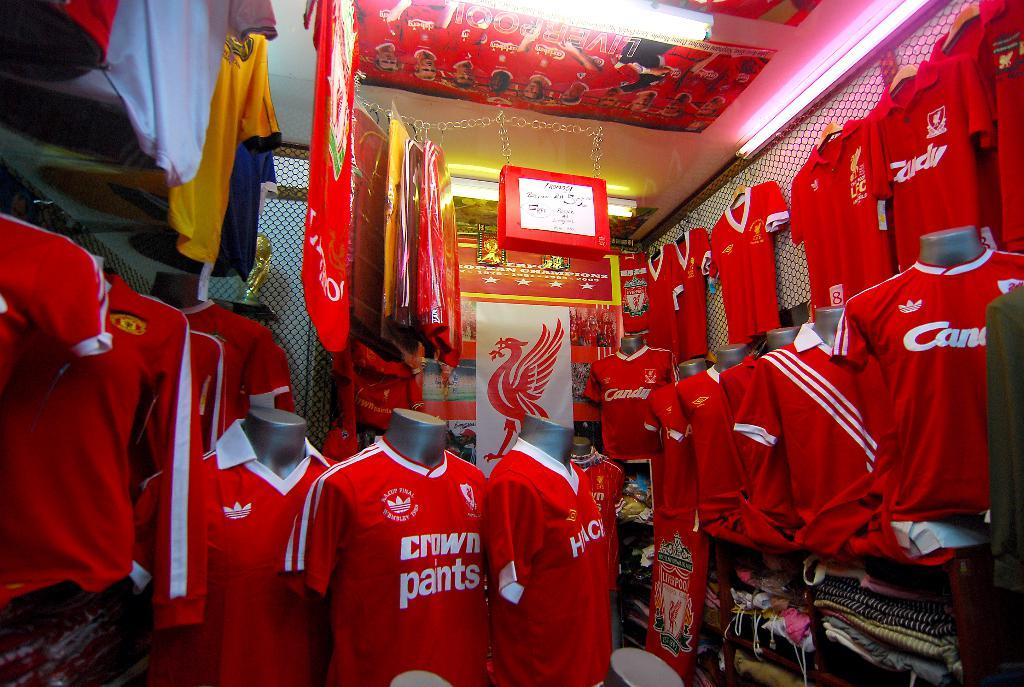<image>
Offer a succinct explanation of the picture presented. a store full of red sports shirt for crown pants 